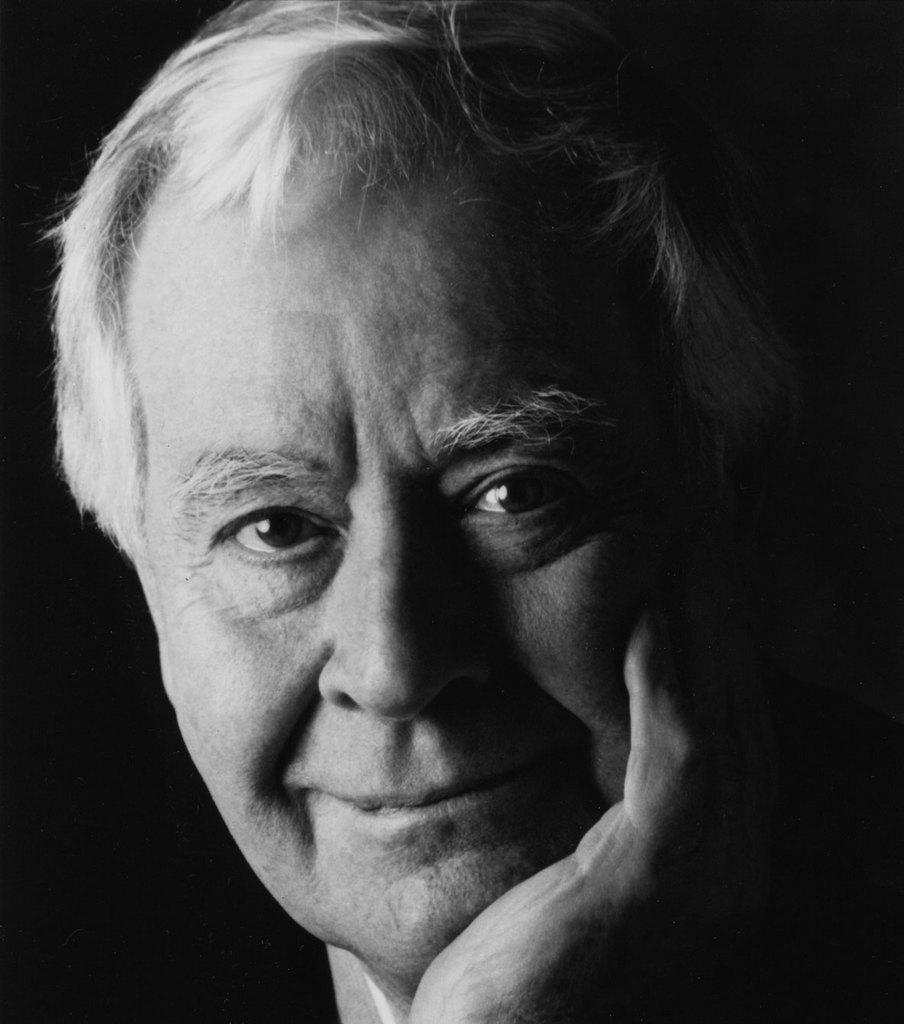How would you summarize this image in a sentence or two? In this picture I can observe a man in the middle of the picture. The background is dark. 